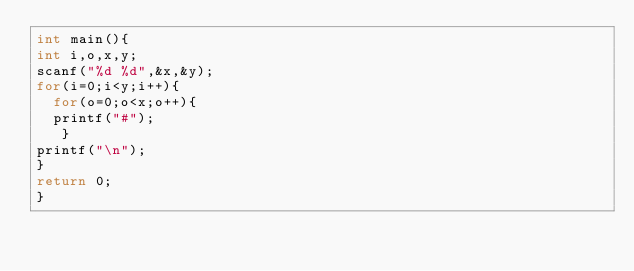Convert code to text. <code><loc_0><loc_0><loc_500><loc_500><_C_>int main(){
int i,o,x,y;
scanf("%d %d",&x,&y);
for(i=0;i<y;i++){
  for(o=0;o<x;o++){
  printf("#");
   }
printf("\n");
}
return 0;
}</code> 